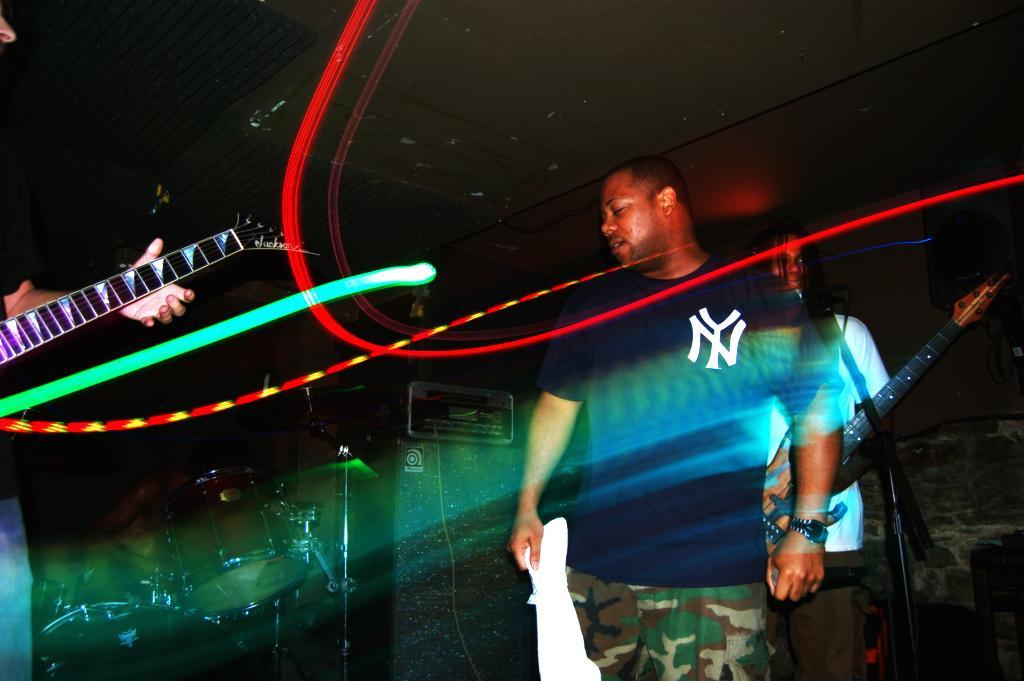Describe this image in one or two sentences. In this picture a man standing and another person on to the left holding the guitar 